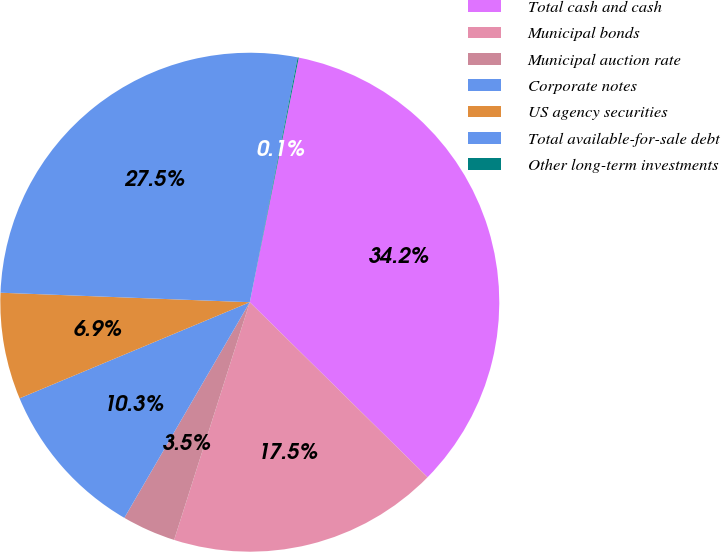Convert chart. <chart><loc_0><loc_0><loc_500><loc_500><pie_chart><fcel>Total cash and cash<fcel>Municipal bonds<fcel>Municipal auction rate<fcel>Corporate notes<fcel>US agency securities<fcel>Total available-for-sale debt<fcel>Other long-term investments<nl><fcel>34.23%<fcel>17.53%<fcel>3.48%<fcel>10.32%<fcel>6.9%<fcel>27.47%<fcel>0.07%<nl></chart> 